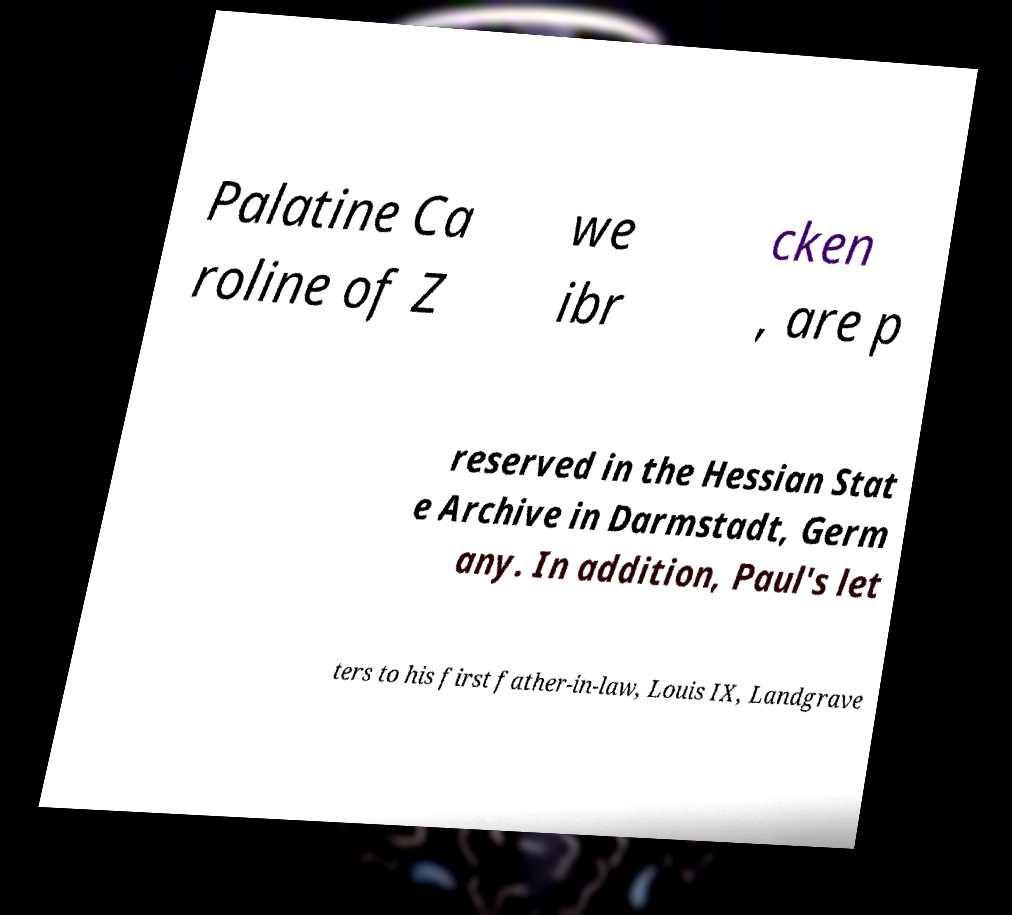Please identify and transcribe the text found in this image. Palatine Ca roline of Z we ibr cken , are p reserved in the Hessian Stat e Archive in Darmstadt, Germ any. In addition, Paul's let ters to his first father-in-law, Louis IX, Landgrave 